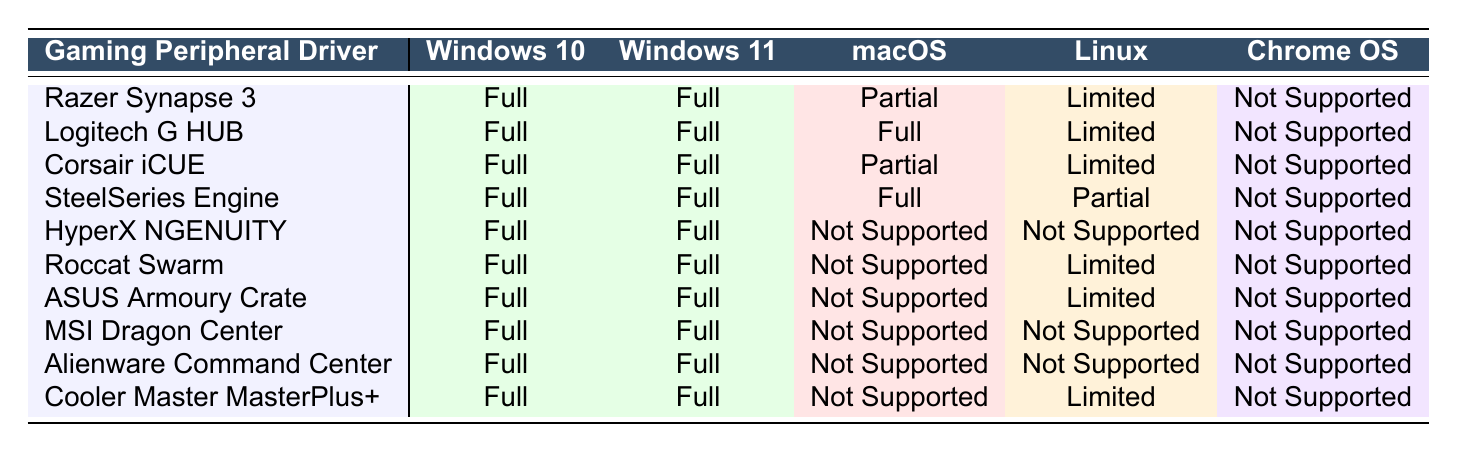What is the compatibility status of Razer Synapse 3 on macOS? The table shows "Partial" under the macOS column for Razer Synapse 3, indicating limited functionality.
Answer: Partial Which gaming peripheral drivers are supported on Chrome OS? The table indicates "Not Supported" for all listed gaming peripheral drivers under the Chrome OS column.
Answer: None How many gaming peripheral drivers provide full support on Windows 11? By counting the "Full" entries in the Windows 11 column, there are 10 devices that provide full support.
Answer: 10 Is HyperX NGENUITY supported on any operating system other than Windows? The table shows "Not Supported" under macOS, Linux, and Chrome OS for HyperX NGENUITY, confirming it’s only supported on Windows.
Answer: No Which driver has limited support on Linux? Examining the Linux column, Razer Synapse 3, Corsair iCUE, Roccat Swarm, ASUS Armoury Crate, and Cooler Master MasterPlus+ all have "Limited" support.
Answer: Razer Synapse 3, Corsair iCUE, Roccat Swarm, ASUS Armoury Crate, Cooler Master MasterPlus+ How many drivers are fully supported on both Windows 10 and Windows 11? The same drivers are fully supported on both Windows 10 and Windows 11, and reviewing the entries, all 10 drivers show "Full" for both.
Answer: 10 Are there any drivers that provide full support on macOS? By checking the macOS column, only Logitech G HUB and SteelSeries Engine show "Full," indicating they are fully supported.
Answer: Yes What is the average compatibility level for Corsair iCUE across all operating systems? Corsair iCUE has "Full" for Windows 10, Windows 11, "Partial" for macOS, and "Limited" for Linux and Chrome OS. Assigning values (Full=100, Partial=50, Limited=25, Not Supported=0), the average is (100 + 100 + 50 + 25 + 0) / 5 = 55. The average compatibility level is therefore 55.
Answer: 55 Which gaming peripheral driver has the least support across all operating systems? HyperX NGENUITY shows "Not Supported" for macOS, Linux, and Chrome OS while supporting only Windows, making it the least compatible driver.
Answer: HyperX NGENUITY How many drivers have partial support on macOS? Checking the macOS column, Razer Synapse 3 and Corsair iCUE have "Partial" support, indicating there are 2 drivers with this level of compatibility on macOS.
Answer: 2 